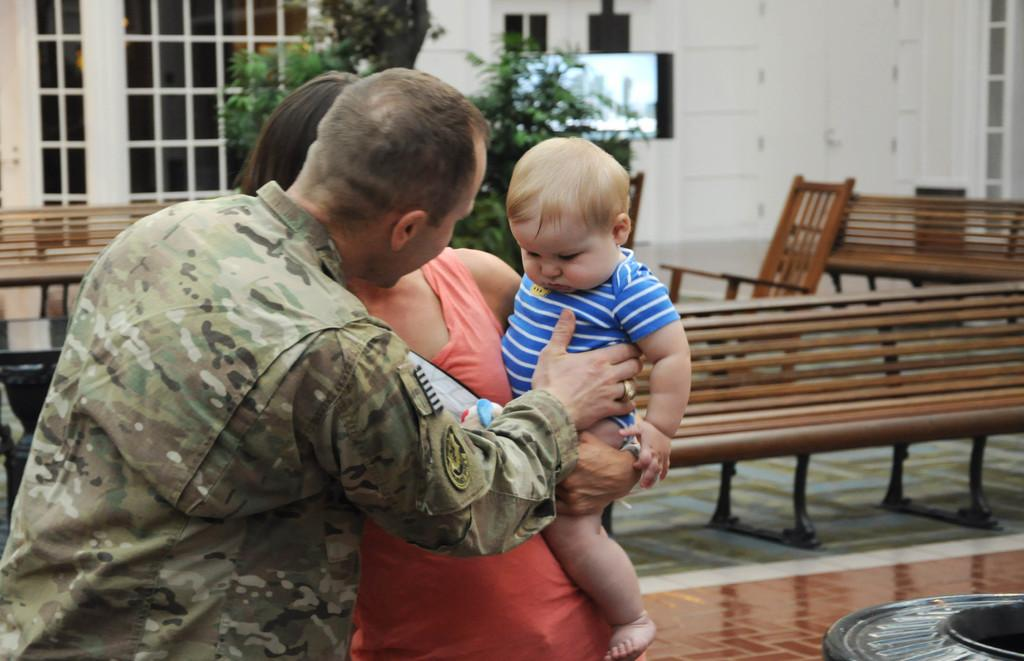How many people are present in the image? There are three people in the image: a man, a woman, and a baby. What are the people in the image doing? The baby, man, and woman are standing. What can be seen in the background of the image? There is a chair, benches, a tree, and a screen in the background of the image. What is the condition of the baby's feet in the image? There is no information about the baby's feet in the image, so it cannot be determined. 